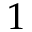<formula> <loc_0><loc_0><loc_500><loc_500>1</formula> 